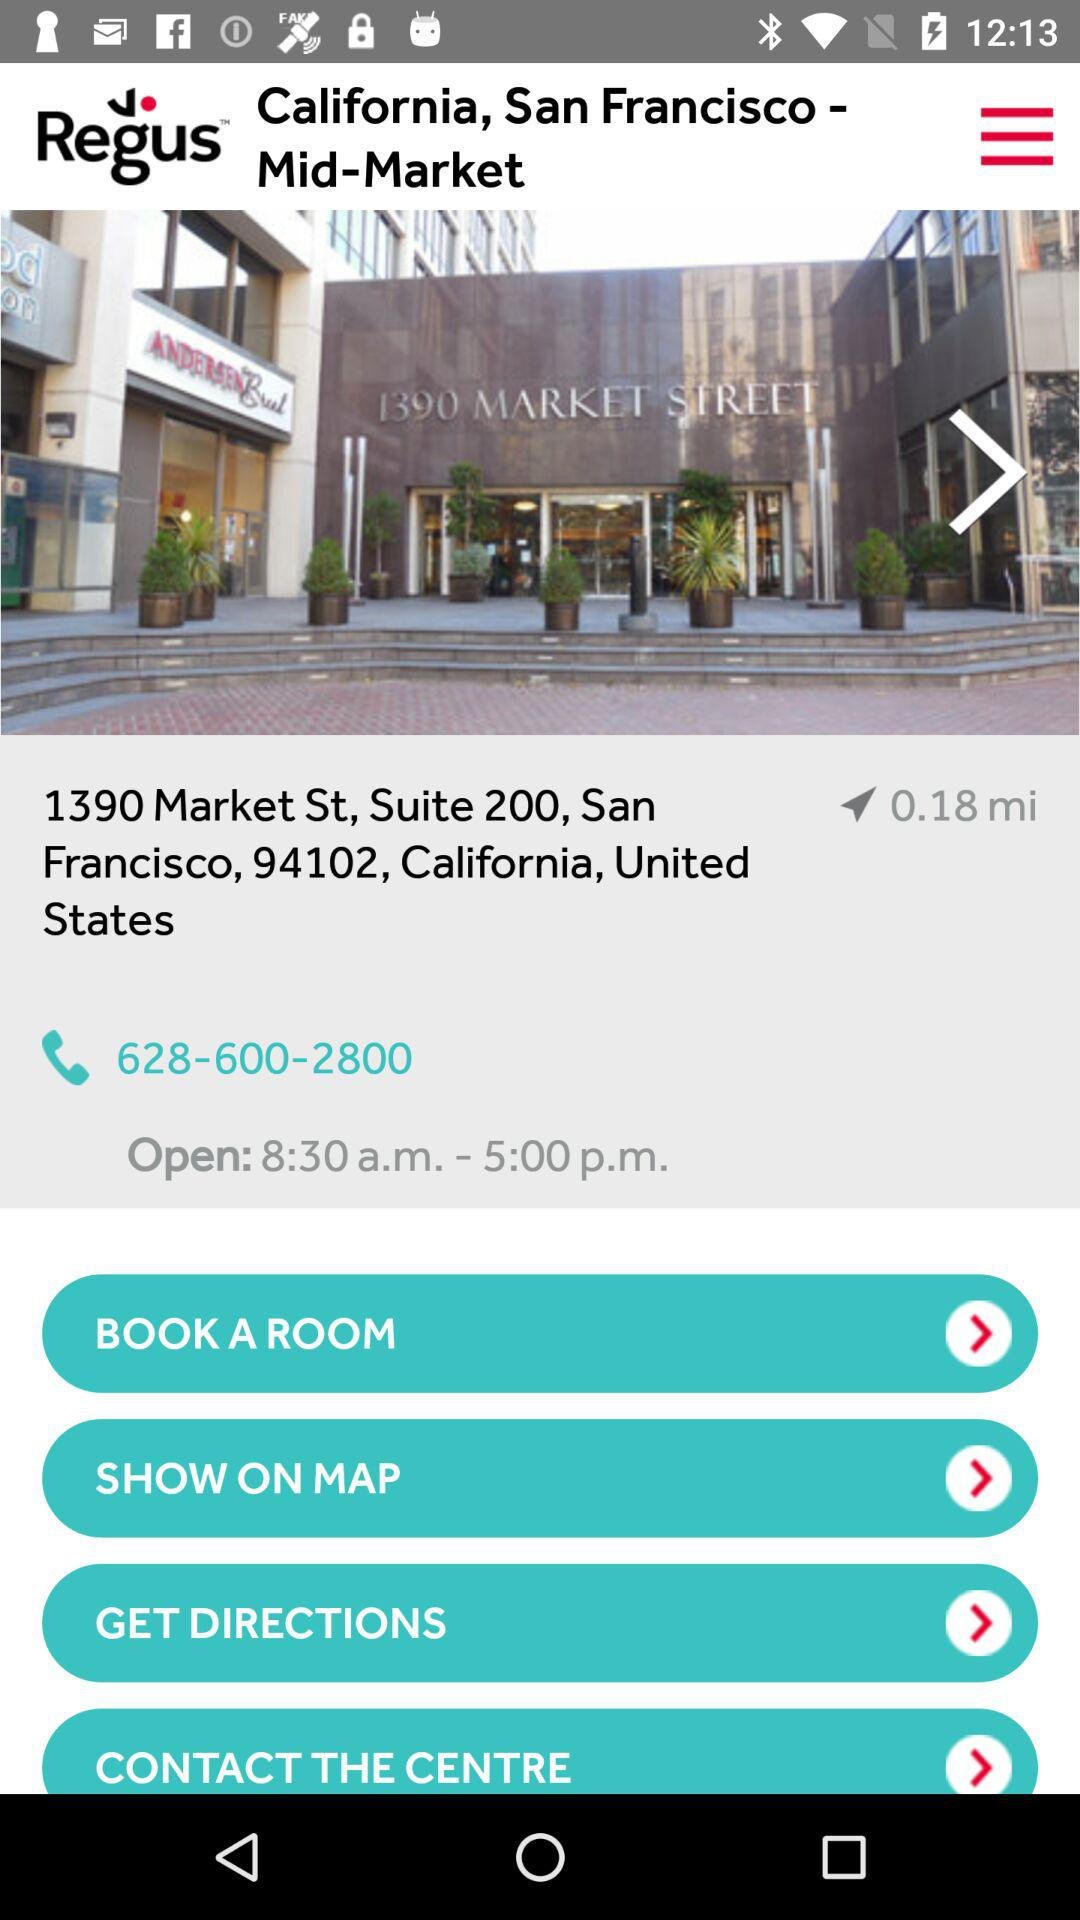What are the opening and closing hours? The hours of opening and closing are 8:30 a.m. and 5:00 p.m., respectively. 